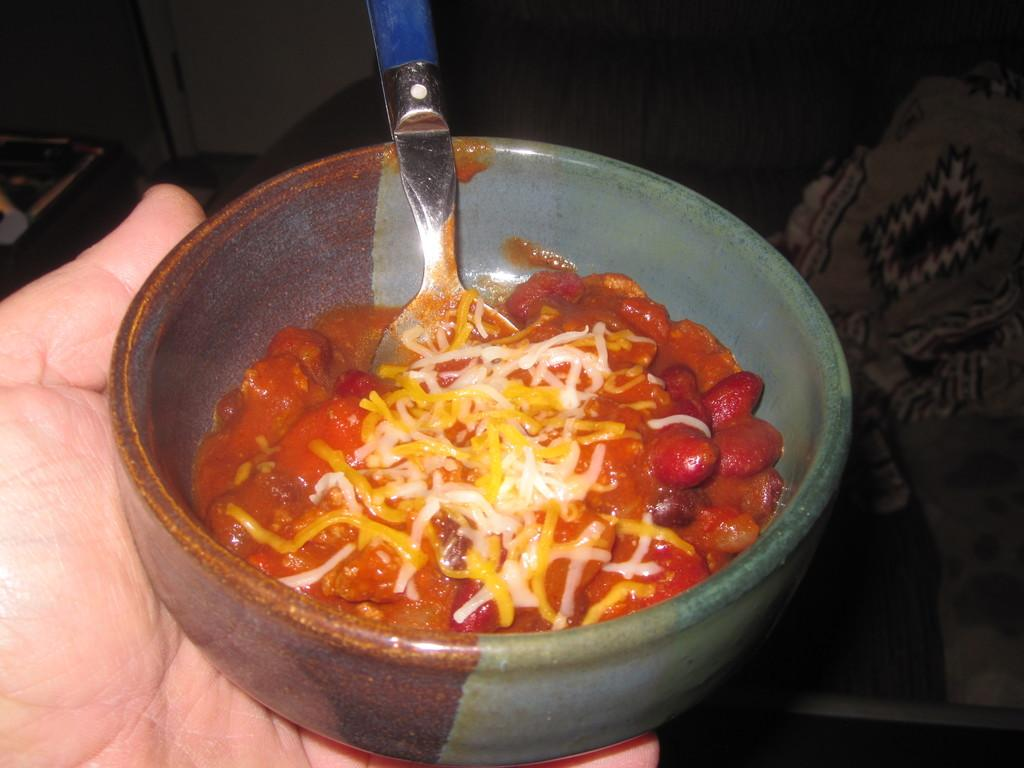What is being held by the hand in the image? The hand is holding a bowl in the image. What is inside the bowl that the hand is holding? The bowl contains food. What utensil is visible in the image? There is a spoon in the image. Can you describe the background of the image? The background of the image is blurred. What type of snake can be seen slithering in the background of the image? There is no snake present in the image; the background is blurred. What does the person's voice sound like in the image? There is no voice present in the image, as it is a still image and not a video or audio recording. 